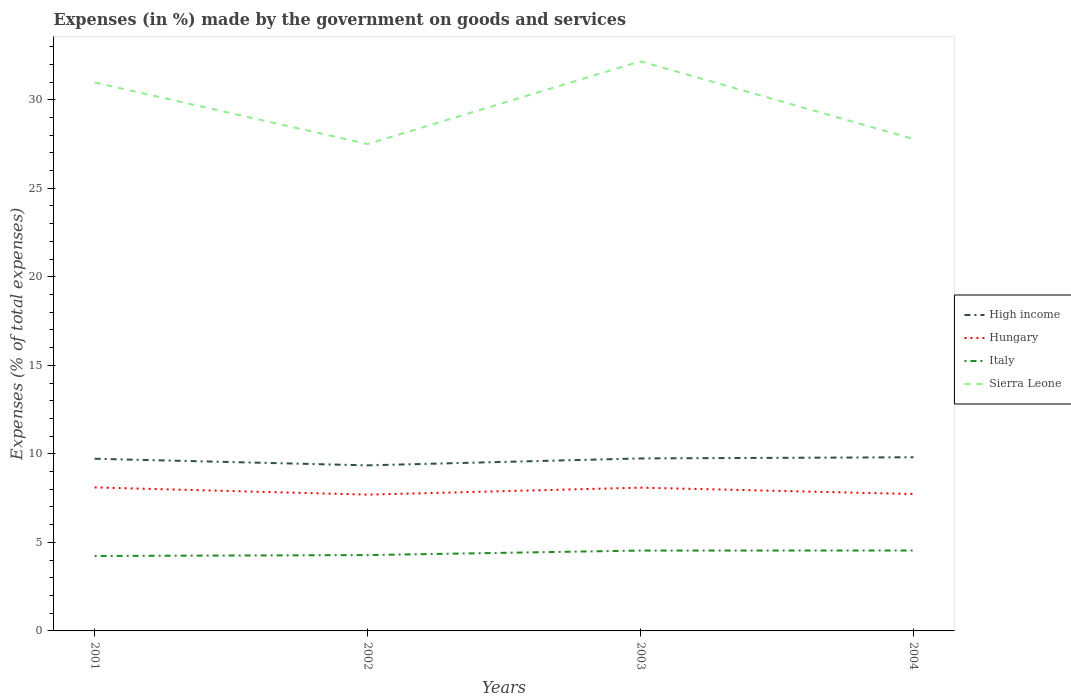Is the number of lines equal to the number of legend labels?
Your answer should be compact. Yes. Across all years, what is the maximum percentage of expenses made by the government on goods and services in High income?
Give a very brief answer. 9.35. What is the total percentage of expenses made by the government on goods and services in High income in the graph?
Provide a short and direct response. -0.46. What is the difference between the highest and the second highest percentage of expenses made by the government on goods and services in High income?
Your answer should be compact. 0.46. Does the graph contain any zero values?
Keep it short and to the point. No. Where does the legend appear in the graph?
Your answer should be compact. Center right. What is the title of the graph?
Offer a very short reply. Expenses (in %) made by the government on goods and services. Does "Marshall Islands" appear as one of the legend labels in the graph?
Make the answer very short. No. What is the label or title of the Y-axis?
Ensure brevity in your answer.  Expenses (% of total expenses). What is the Expenses (% of total expenses) of High income in 2001?
Give a very brief answer. 9.72. What is the Expenses (% of total expenses) of Hungary in 2001?
Make the answer very short. 8.1. What is the Expenses (% of total expenses) of Italy in 2001?
Provide a succinct answer. 4.23. What is the Expenses (% of total expenses) of Sierra Leone in 2001?
Your answer should be very brief. 30.98. What is the Expenses (% of total expenses) in High income in 2002?
Make the answer very short. 9.35. What is the Expenses (% of total expenses) in Hungary in 2002?
Offer a very short reply. 7.7. What is the Expenses (% of total expenses) in Italy in 2002?
Offer a terse response. 4.28. What is the Expenses (% of total expenses) in Sierra Leone in 2002?
Offer a terse response. 27.5. What is the Expenses (% of total expenses) in High income in 2003?
Your answer should be very brief. 9.74. What is the Expenses (% of total expenses) of Hungary in 2003?
Provide a succinct answer. 8.09. What is the Expenses (% of total expenses) in Italy in 2003?
Make the answer very short. 4.54. What is the Expenses (% of total expenses) in Sierra Leone in 2003?
Keep it short and to the point. 32.17. What is the Expenses (% of total expenses) in High income in 2004?
Provide a succinct answer. 9.81. What is the Expenses (% of total expenses) of Hungary in 2004?
Make the answer very short. 7.73. What is the Expenses (% of total expenses) in Italy in 2004?
Provide a succinct answer. 4.54. What is the Expenses (% of total expenses) in Sierra Leone in 2004?
Your answer should be very brief. 27.78. Across all years, what is the maximum Expenses (% of total expenses) in High income?
Offer a terse response. 9.81. Across all years, what is the maximum Expenses (% of total expenses) in Hungary?
Your answer should be very brief. 8.1. Across all years, what is the maximum Expenses (% of total expenses) of Italy?
Give a very brief answer. 4.54. Across all years, what is the maximum Expenses (% of total expenses) of Sierra Leone?
Ensure brevity in your answer.  32.17. Across all years, what is the minimum Expenses (% of total expenses) of High income?
Offer a very short reply. 9.35. Across all years, what is the minimum Expenses (% of total expenses) in Hungary?
Your answer should be very brief. 7.7. Across all years, what is the minimum Expenses (% of total expenses) in Italy?
Make the answer very short. 4.23. Across all years, what is the minimum Expenses (% of total expenses) of Sierra Leone?
Your response must be concise. 27.5. What is the total Expenses (% of total expenses) in High income in the graph?
Your response must be concise. 38.63. What is the total Expenses (% of total expenses) of Hungary in the graph?
Keep it short and to the point. 31.62. What is the total Expenses (% of total expenses) of Italy in the graph?
Make the answer very short. 17.6. What is the total Expenses (% of total expenses) in Sierra Leone in the graph?
Give a very brief answer. 118.43. What is the difference between the Expenses (% of total expenses) in High income in 2001 and that in 2002?
Keep it short and to the point. 0.37. What is the difference between the Expenses (% of total expenses) of Hungary in 2001 and that in 2002?
Provide a short and direct response. 0.41. What is the difference between the Expenses (% of total expenses) in Italy in 2001 and that in 2002?
Your answer should be compact. -0.05. What is the difference between the Expenses (% of total expenses) of Sierra Leone in 2001 and that in 2002?
Provide a short and direct response. 3.48. What is the difference between the Expenses (% of total expenses) in High income in 2001 and that in 2003?
Give a very brief answer. -0.02. What is the difference between the Expenses (% of total expenses) of Hungary in 2001 and that in 2003?
Offer a terse response. 0.01. What is the difference between the Expenses (% of total expenses) of Italy in 2001 and that in 2003?
Offer a very short reply. -0.3. What is the difference between the Expenses (% of total expenses) of Sierra Leone in 2001 and that in 2003?
Your answer should be compact. -1.19. What is the difference between the Expenses (% of total expenses) in High income in 2001 and that in 2004?
Your answer should be compact. -0.08. What is the difference between the Expenses (% of total expenses) of Hungary in 2001 and that in 2004?
Keep it short and to the point. 0.37. What is the difference between the Expenses (% of total expenses) in Italy in 2001 and that in 2004?
Keep it short and to the point. -0.31. What is the difference between the Expenses (% of total expenses) in Sierra Leone in 2001 and that in 2004?
Provide a succinct answer. 3.2. What is the difference between the Expenses (% of total expenses) in High income in 2002 and that in 2003?
Your answer should be very brief. -0.39. What is the difference between the Expenses (% of total expenses) of Hungary in 2002 and that in 2003?
Your answer should be compact. -0.4. What is the difference between the Expenses (% of total expenses) of Italy in 2002 and that in 2003?
Offer a terse response. -0.25. What is the difference between the Expenses (% of total expenses) in Sierra Leone in 2002 and that in 2003?
Your answer should be compact. -4.67. What is the difference between the Expenses (% of total expenses) of High income in 2002 and that in 2004?
Offer a terse response. -0.46. What is the difference between the Expenses (% of total expenses) in Hungary in 2002 and that in 2004?
Keep it short and to the point. -0.04. What is the difference between the Expenses (% of total expenses) in Italy in 2002 and that in 2004?
Provide a succinct answer. -0.26. What is the difference between the Expenses (% of total expenses) of Sierra Leone in 2002 and that in 2004?
Give a very brief answer. -0.28. What is the difference between the Expenses (% of total expenses) of High income in 2003 and that in 2004?
Offer a terse response. -0.07. What is the difference between the Expenses (% of total expenses) of Hungary in 2003 and that in 2004?
Keep it short and to the point. 0.36. What is the difference between the Expenses (% of total expenses) of Italy in 2003 and that in 2004?
Keep it short and to the point. -0. What is the difference between the Expenses (% of total expenses) of Sierra Leone in 2003 and that in 2004?
Keep it short and to the point. 4.39. What is the difference between the Expenses (% of total expenses) in High income in 2001 and the Expenses (% of total expenses) in Hungary in 2002?
Your answer should be very brief. 2.03. What is the difference between the Expenses (% of total expenses) of High income in 2001 and the Expenses (% of total expenses) of Italy in 2002?
Keep it short and to the point. 5.44. What is the difference between the Expenses (% of total expenses) in High income in 2001 and the Expenses (% of total expenses) in Sierra Leone in 2002?
Provide a short and direct response. -17.78. What is the difference between the Expenses (% of total expenses) of Hungary in 2001 and the Expenses (% of total expenses) of Italy in 2002?
Your answer should be compact. 3.82. What is the difference between the Expenses (% of total expenses) of Hungary in 2001 and the Expenses (% of total expenses) of Sierra Leone in 2002?
Provide a succinct answer. -19.4. What is the difference between the Expenses (% of total expenses) of Italy in 2001 and the Expenses (% of total expenses) of Sierra Leone in 2002?
Offer a terse response. -23.27. What is the difference between the Expenses (% of total expenses) of High income in 2001 and the Expenses (% of total expenses) of Hungary in 2003?
Provide a short and direct response. 1.63. What is the difference between the Expenses (% of total expenses) of High income in 2001 and the Expenses (% of total expenses) of Italy in 2003?
Keep it short and to the point. 5.19. What is the difference between the Expenses (% of total expenses) of High income in 2001 and the Expenses (% of total expenses) of Sierra Leone in 2003?
Make the answer very short. -22.45. What is the difference between the Expenses (% of total expenses) in Hungary in 2001 and the Expenses (% of total expenses) in Italy in 2003?
Offer a terse response. 3.57. What is the difference between the Expenses (% of total expenses) in Hungary in 2001 and the Expenses (% of total expenses) in Sierra Leone in 2003?
Offer a very short reply. -24.07. What is the difference between the Expenses (% of total expenses) in Italy in 2001 and the Expenses (% of total expenses) in Sierra Leone in 2003?
Give a very brief answer. -27.94. What is the difference between the Expenses (% of total expenses) of High income in 2001 and the Expenses (% of total expenses) of Hungary in 2004?
Your answer should be very brief. 1.99. What is the difference between the Expenses (% of total expenses) of High income in 2001 and the Expenses (% of total expenses) of Italy in 2004?
Your answer should be compact. 5.18. What is the difference between the Expenses (% of total expenses) of High income in 2001 and the Expenses (% of total expenses) of Sierra Leone in 2004?
Offer a very short reply. -18.06. What is the difference between the Expenses (% of total expenses) in Hungary in 2001 and the Expenses (% of total expenses) in Italy in 2004?
Make the answer very short. 3.56. What is the difference between the Expenses (% of total expenses) of Hungary in 2001 and the Expenses (% of total expenses) of Sierra Leone in 2004?
Your response must be concise. -19.68. What is the difference between the Expenses (% of total expenses) of Italy in 2001 and the Expenses (% of total expenses) of Sierra Leone in 2004?
Give a very brief answer. -23.55. What is the difference between the Expenses (% of total expenses) in High income in 2002 and the Expenses (% of total expenses) in Hungary in 2003?
Offer a very short reply. 1.26. What is the difference between the Expenses (% of total expenses) in High income in 2002 and the Expenses (% of total expenses) in Italy in 2003?
Keep it short and to the point. 4.81. What is the difference between the Expenses (% of total expenses) in High income in 2002 and the Expenses (% of total expenses) in Sierra Leone in 2003?
Offer a terse response. -22.82. What is the difference between the Expenses (% of total expenses) of Hungary in 2002 and the Expenses (% of total expenses) of Italy in 2003?
Give a very brief answer. 3.16. What is the difference between the Expenses (% of total expenses) of Hungary in 2002 and the Expenses (% of total expenses) of Sierra Leone in 2003?
Keep it short and to the point. -24.48. What is the difference between the Expenses (% of total expenses) of Italy in 2002 and the Expenses (% of total expenses) of Sierra Leone in 2003?
Provide a succinct answer. -27.89. What is the difference between the Expenses (% of total expenses) of High income in 2002 and the Expenses (% of total expenses) of Hungary in 2004?
Ensure brevity in your answer.  1.62. What is the difference between the Expenses (% of total expenses) of High income in 2002 and the Expenses (% of total expenses) of Italy in 2004?
Your answer should be very brief. 4.81. What is the difference between the Expenses (% of total expenses) in High income in 2002 and the Expenses (% of total expenses) in Sierra Leone in 2004?
Provide a short and direct response. -18.43. What is the difference between the Expenses (% of total expenses) of Hungary in 2002 and the Expenses (% of total expenses) of Italy in 2004?
Offer a terse response. 3.16. What is the difference between the Expenses (% of total expenses) in Hungary in 2002 and the Expenses (% of total expenses) in Sierra Leone in 2004?
Keep it short and to the point. -20.09. What is the difference between the Expenses (% of total expenses) in Italy in 2002 and the Expenses (% of total expenses) in Sierra Leone in 2004?
Give a very brief answer. -23.5. What is the difference between the Expenses (% of total expenses) in High income in 2003 and the Expenses (% of total expenses) in Hungary in 2004?
Your answer should be very brief. 2.01. What is the difference between the Expenses (% of total expenses) of High income in 2003 and the Expenses (% of total expenses) of Italy in 2004?
Make the answer very short. 5.2. What is the difference between the Expenses (% of total expenses) in High income in 2003 and the Expenses (% of total expenses) in Sierra Leone in 2004?
Provide a short and direct response. -18.04. What is the difference between the Expenses (% of total expenses) of Hungary in 2003 and the Expenses (% of total expenses) of Italy in 2004?
Your response must be concise. 3.55. What is the difference between the Expenses (% of total expenses) in Hungary in 2003 and the Expenses (% of total expenses) in Sierra Leone in 2004?
Your answer should be compact. -19.69. What is the difference between the Expenses (% of total expenses) of Italy in 2003 and the Expenses (% of total expenses) of Sierra Leone in 2004?
Your answer should be very brief. -23.24. What is the average Expenses (% of total expenses) of High income per year?
Your response must be concise. 9.66. What is the average Expenses (% of total expenses) of Hungary per year?
Make the answer very short. 7.91. What is the average Expenses (% of total expenses) in Italy per year?
Offer a very short reply. 4.4. What is the average Expenses (% of total expenses) in Sierra Leone per year?
Your response must be concise. 29.61. In the year 2001, what is the difference between the Expenses (% of total expenses) of High income and Expenses (% of total expenses) of Hungary?
Provide a succinct answer. 1.62. In the year 2001, what is the difference between the Expenses (% of total expenses) of High income and Expenses (% of total expenses) of Italy?
Provide a succinct answer. 5.49. In the year 2001, what is the difference between the Expenses (% of total expenses) of High income and Expenses (% of total expenses) of Sierra Leone?
Your response must be concise. -21.25. In the year 2001, what is the difference between the Expenses (% of total expenses) of Hungary and Expenses (% of total expenses) of Italy?
Offer a very short reply. 3.87. In the year 2001, what is the difference between the Expenses (% of total expenses) in Hungary and Expenses (% of total expenses) in Sierra Leone?
Offer a very short reply. -22.87. In the year 2001, what is the difference between the Expenses (% of total expenses) of Italy and Expenses (% of total expenses) of Sierra Leone?
Provide a succinct answer. -26.74. In the year 2002, what is the difference between the Expenses (% of total expenses) of High income and Expenses (% of total expenses) of Hungary?
Ensure brevity in your answer.  1.65. In the year 2002, what is the difference between the Expenses (% of total expenses) in High income and Expenses (% of total expenses) in Italy?
Give a very brief answer. 5.07. In the year 2002, what is the difference between the Expenses (% of total expenses) of High income and Expenses (% of total expenses) of Sierra Leone?
Offer a very short reply. -18.15. In the year 2002, what is the difference between the Expenses (% of total expenses) of Hungary and Expenses (% of total expenses) of Italy?
Make the answer very short. 3.41. In the year 2002, what is the difference between the Expenses (% of total expenses) in Hungary and Expenses (% of total expenses) in Sierra Leone?
Provide a succinct answer. -19.8. In the year 2002, what is the difference between the Expenses (% of total expenses) of Italy and Expenses (% of total expenses) of Sierra Leone?
Provide a short and direct response. -23.22. In the year 2003, what is the difference between the Expenses (% of total expenses) in High income and Expenses (% of total expenses) in Hungary?
Offer a terse response. 1.65. In the year 2003, what is the difference between the Expenses (% of total expenses) of High income and Expenses (% of total expenses) of Italy?
Offer a terse response. 5.2. In the year 2003, what is the difference between the Expenses (% of total expenses) in High income and Expenses (% of total expenses) in Sierra Leone?
Provide a short and direct response. -22.43. In the year 2003, what is the difference between the Expenses (% of total expenses) in Hungary and Expenses (% of total expenses) in Italy?
Offer a terse response. 3.55. In the year 2003, what is the difference between the Expenses (% of total expenses) of Hungary and Expenses (% of total expenses) of Sierra Leone?
Your answer should be very brief. -24.08. In the year 2003, what is the difference between the Expenses (% of total expenses) in Italy and Expenses (% of total expenses) in Sierra Leone?
Provide a succinct answer. -27.63. In the year 2004, what is the difference between the Expenses (% of total expenses) in High income and Expenses (% of total expenses) in Hungary?
Ensure brevity in your answer.  2.08. In the year 2004, what is the difference between the Expenses (% of total expenses) of High income and Expenses (% of total expenses) of Italy?
Give a very brief answer. 5.27. In the year 2004, what is the difference between the Expenses (% of total expenses) in High income and Expenses (% of total expenses) in Sierra Leone?
Offer a terse response. -17.97. In the year 2004, what is the difference between the Expenses (% of total expenses) in Hungary and Expenses (% of total expenses) in Italy?
Provide a succinct answer. 3.19. In the year 2004, what is the difference between the Expenses (% of total expenses) of Hungary and Expenses (% of total expenses) of Sierra Leone?
Your response must be concise. -20.05. In the year 2004, what is the difference between the Expenses (% of total expenses) of Italy and Expenses (% of total expenses) of Sierra Leone?
Make the answer very short. -23.24. What is the ratio of the Expenses (% of total expenses) of High income in 2001 to that in 2002?
Provide a short and direct response. 1.04. What is the ratio of the Expenses (% of total expenses) of Hungary in 2001 to that in 2002?
Ensure brevity in your answer.  1.05. What is the ratio of the Expenses (% of total expenses) in Italy in 2001 to that in 2002?
Your response must be concise. 0.99. What is the ratio of the Expenses (% of total expenses) of Sierra Leone in 2001 to that in 2002?
Keep it short and to the point. 1.13. What is the ratio of the Expenses (% of total expenses) in High income in 2001 to that in 2003?
Offer a very short reply. 1. What is the ratio of the Expenses (% of total expenses) of Italy in 2001 to that in 2003?
Provide a succinct answer. 0.93. What is the ratio of the Expenses (% of total expenses) of Sierra Leone in 2001 to that in 2003?
Offer a very short reply. 0.96. What is the ratio of the Expenses (% of total expenses) in High income in 2001 to that in 2004?
Your response must be concise. 0.99. What is the ratio of the Expenses (% of total expenses) of Hungary in 2001 to that in 2004?
Make the answer very short. 1.05. What is the ratio of the Expenses (% of total expenses) of Italy in 2001 to that in 2004?
Keep it short and to the point. 0.93. What is the ratio of the Expenses (% of total expenses) of Sierra Leone in 2001 to that in 2004?
Make the answer very short. 1.11. What is the ratio of the Expenses (% of total expenses) of High income in 2002 to that in 2003?
Keep it short and to the point. 0.96. What is the ratio of the Expenses (% of total expenses) of Hungary in 2002 to that in 2003?
Give a very brief answer. 0.95. What is the ratio of the Expenses (% of total expenses) in Italy in 2002 to that in 2003?
Offer a very short reply. 0.94. What is the ratio of the Expenses (% of total expenses) of Sierra Leone in 2002 to that in 2003?
Provide a succinct answer. 0.85. What is the ratio of the Expenses (% of total expenses) in High income in 2002 to that in 2004?
Give a very brief answer. 0.95. What is the ratio of the Expenses (% of total expenses) of Italy in 2002 to that in 2004?
Provide a short and direct response. 0.94. What is the ratio of the Expenses (% of total expenses) in Hungary in 2003 to that in 2004?
Offer a terse response. 1.05. What is the ratio of the Expenses (% of total expenses) of Sierra Leone in 2003 to that in 2004?
Offer a terse response. 1.16. What is the difference between the highest and the second highest Expenses (% of total expenses) of High income?
Give a very brief answer. 0.07. What is the difference between the highest and the second highest Expenses (% of total expenses) of Hungary?
Your answer should be compact. 0.01. What is the difference between the highest and the second highest Expenses (% of total expenses) of Italy?
Your response must be concise. 0. What is the difference between the highest and the second highest Expenses (% of total expenses) in Sierra Leone?
Give a very brief answer. 1.19. What is the difference between the highest and the lowest Expenses (% of total expenses) of High income?
Keep it short and to the point. 0.46. What is the difference between the highest and the lowest Expenses (% of total expenses) in Hungary?
Ensure brevity in your answer.  0.41. What is the difference between the highest and the lowest Expenses (% of total expenses) in Italy?
Make the answer very short. 0.31. What is the difference between the highest and the lowest Expenses (% of total expenses) in Sierra Leone?
Make the answer very short. 4.67. 